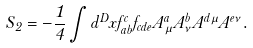<formula> <loc_0><loc_0><loc_500><loc_500>S _ { 2 } = - \frac { 1 } { 4 } \int d ^ { D } x f _ { a b } ^ { c } f _ { c d e } A _ { \mu } ^ { a } A _ { \nu } ^ { b } A ^ { d \mu } A ^ { e \nu } .</formula> 